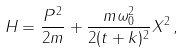Convert formula to latex. <formula><loc_0><loc_0><loc_500><loc_500>H = \frac { P ^ { 2 } } { 2 m } + \frac { m \omega _ { 0 } ^ { 2 } } { 2 ( t + k ) ^ { 2 } } X ^ { 2 } \, ,</formula> 